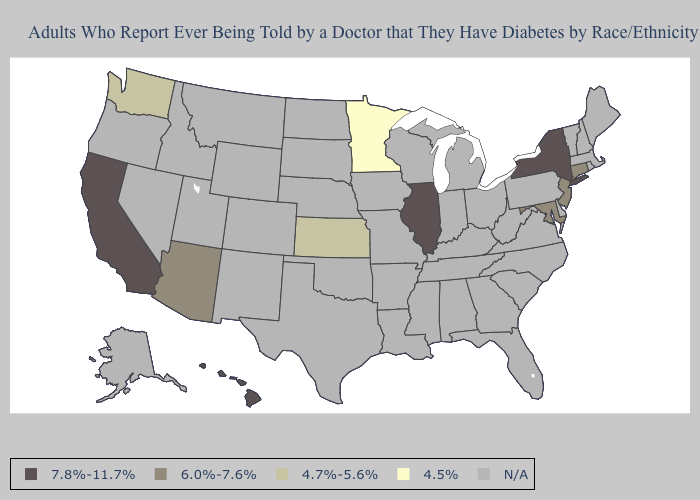Among the states that border Oregon , does California have the highest value?
Short answer required. Yes. What is the value of Vermont?
Short answer required. N/A. Does Connecticut have the highest value in the Northeast?
Write a very short answer. No. Name the states that have a value in the range 4.7%-5.6%?
Concise answer only. Kansas, Washington. What is the value of Florida?
Answer briefly. N/A. Which states have the lowest value in the USA?
Be succinct. Minnesota. Among the states that border Oregon , does Washington have the highest value?
Be succinct. No. What is the value of Maryland?
Write a very short answer. 6.0%-7.6%. What is the value of Rhode Island?
Answer briefly. N/A. Name the states that have a value in the range 7.8%-11.7%?
Concise answer only. California, Hawaii, Illinois, New York. What is the value of New Hampshire?
Be succinct. N/A. Does Connecticut have the highest value in the Northeast?
Keep it brief. No. Name the states that have a value in the range 6.0%-7.6%?
Write a very short answer. Arizona, Connecticut, Maryland, New Jersey. 